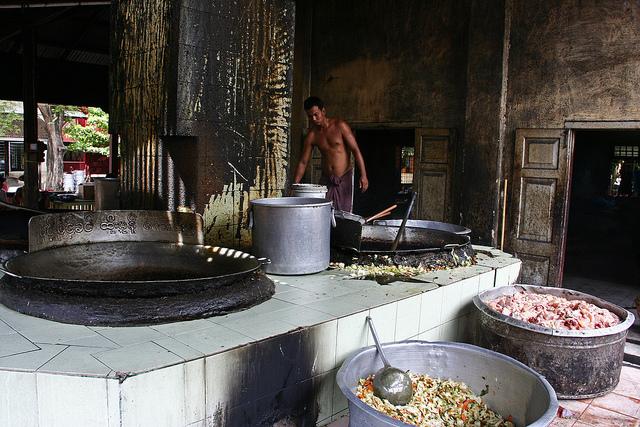What is the hygiene score of this place?
Write a very short answer. Low. Are these people poor?
Quick response, please. No. Is the flame above the pot with the spoon in it?
Quick response, please. No. Is the man overweight?
Concise answer only. No. 